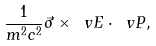<formula> <loc_0><loc_0><loc_500><loc_500>\frac { 1 } { m ^ { 2 } c ^ { 2 } } \vec { \sigma } \times \ v E \cdot \ v P ,</formula> 